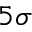Convert formula to latex. <formula><loc_0><loc_0><loc_500><loc_500>5 \sigma</formula> 